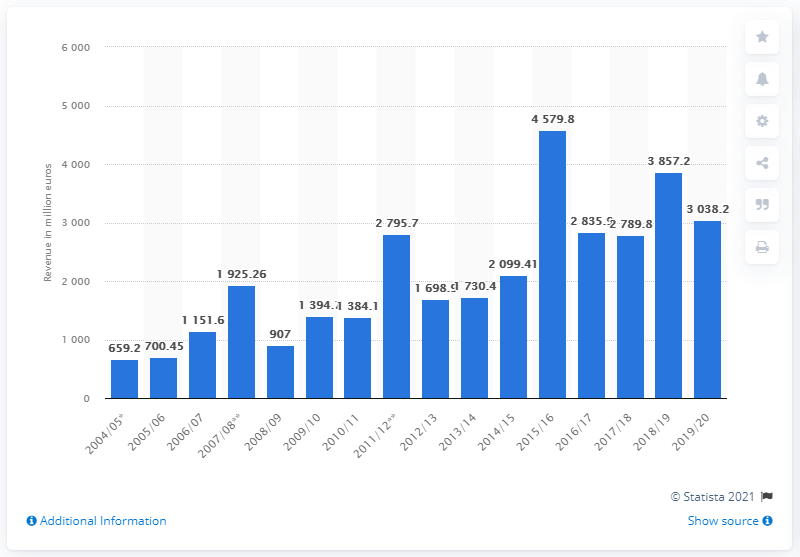Identify some key points in this picture. The next season of the UEFA football season is 2019/20. The total revenue for the 2018/19 season was 3857.2, which represented a significant increase compared to the previous season. 